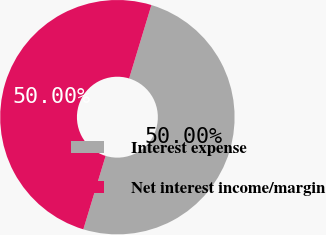Convert chart. <chart><loc_0><loc_0><loc_500><loc_500><pie_chart><fcel>Interest expense<fcel>Net interest income/margin<nl><fcel>50.0%<fcel>50.0%<nl></chart> 